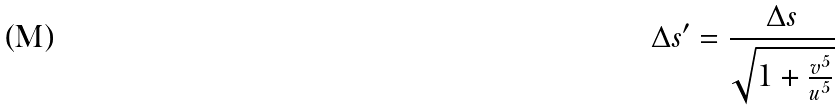<formula> <loc_0><loc_0><loc_500><loc_500>\Delta s ^ { \prime } = \frac { \Delta s } { \sqrt { 1 + \frac { v ^ { 5 } } { u ^ { 5 } } } }</formula> 